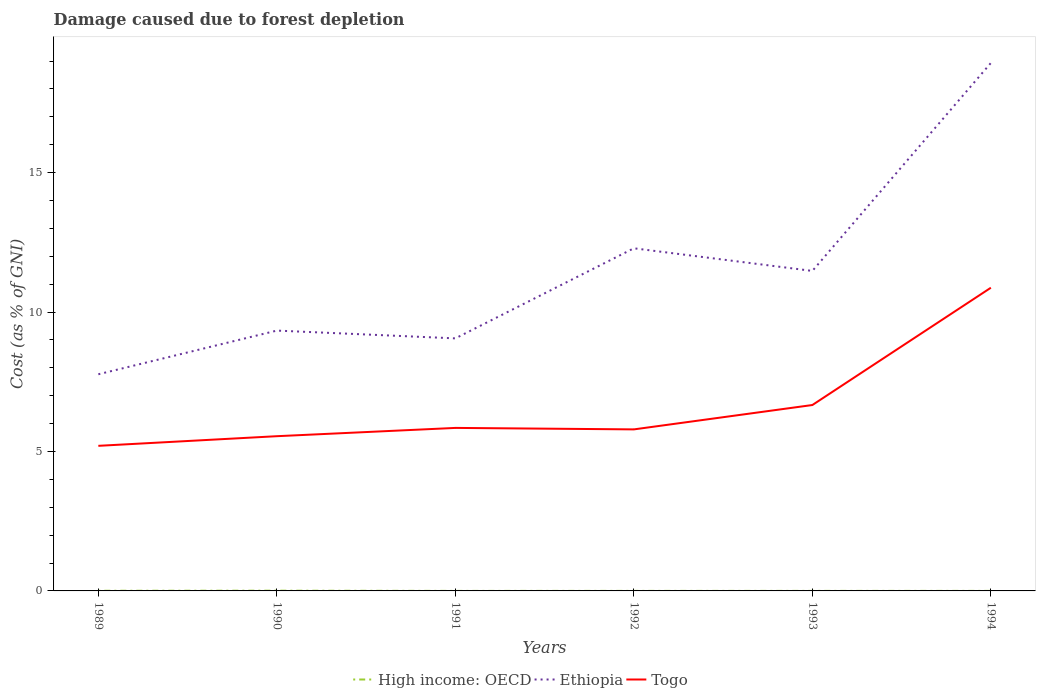Across all years, what is the maximum cost of damage caused due to forest depletion in High income: OECD?
Make the answer very short. 0. What is the total cost of damage caused due to forest depletion in High income: OECD in the graph?
Ensure brevity in your answer.  5.161181673698709e-7. What is the difference between the highest and the second highest cost of damage caused due to forest depletion in Ethiopia?
Your answer should be compact. 11.16. What is the difference between the highest and the lowest cost of damage caused due to forest depletion in Ethiopia?
Give a very brief answer. 2. What is the difference between two consecutive major ticks on the Y-axis?
Ensure brevity in your answer.  5. Are the values on the major ticks of Y-axis written in scientific E-notation?
Your response must be concise. No. Does the graph contain grids?
Provide a succinct answer. No. Where does the legend appear in the graph?
Offer a very short reply. Bottom center. What is the title of the graph?
Keep it short and to the point. Damage caused due to forest depletion. What is the label or title of the Y-axis?
Keep it short and to the point. Cost (as % of GNI). What is the Cost (as % of GNI) of High income: OECD in 1989?
Give a very brief answer. 0.01. What is the Cost (as % of GNI) of Ethiopia in 1989?
Give a very brief answer. 7.77. What is the Cost (as % of GNI) in Togo in 1989?
Your answer should be compact. 5.2. What is the Cost (as % of GNI) of High income: OECD in 1990?
Provide a short and direct response. 0.01. What is the Cost (as % of GNI) in Ethiopia in 1990?
Ensure brevity in your answer.  9.33. What is the Cost (as % of GNI) of Togo in 1990?
Provide a short and direct response. 5.55. What is the Cost (as % of GNI) of High income: OECD in 1991?
Your answer should be compact. 0. What is the Cost (as % of GNI) in Ethiopia in 1991?
Your answer should be very brief. 9.06. What is the Cost (as % of GNI) in Togo in 1991?
Offer a terse response. 5.85. What is the Cost (as % of GNI) in High income: OECD in 1992?
Ensure brevity in your answer.  0. What is the Cost (as % of GNI) of Ethiopia in 1992?
Offer a very short reply. 12.29. What is the Cost (as % of GNI) in Togo in 1992?
Keep it short and to the point. 5.79. What is the Cost (as % of GNI) of High income: OECD in 1993?
Offer a very short reply. 0. What is the Cost (as % of GNI) in Ethiopia in 1993?
Provide a succinct answer. 11.47. What is the Cost (as % of GNI) in Togo in 1993?
Provide a succinct answer. 6.67. What is the Cost (as % of GNI) in High income: OECD in 1994?
Offer a terse response. 0. What is the Cost (as % of GNI) in Ethiopia in 1994?
Ensure brevity in your answer.  18.93. What is the Cost (as % of GNI) in Togo in 1994?
Ensure brevity in your answer.  10.87. Across all years, what is the maximum Cost (as % of GNI) of High income: OECD?
Provide a succinct answer. 0.01. Across all years, what is the maximum Cost (as % of GNI) in Ethiopia?
Your answer should be compact. 18.93. Across all years, what is the maximum Cost (as % of GNI) in Togo?
Provide a succinct answer. 10.87. Across all years, what is the minimum Cost (as % of GNI) in High income: OECD?
Your response must be concise. 0. Across all years, what is the minimum Cost (as % of GNI) in Ethiopia?
Keep it short and to the point. 7.77. Across all years, what is the minimum Cost (as % of GNI) of Togo?
Make the answer very short. 5.2. What is the total Cost (as % of GNI) in High income: OECD in the graph?
Your response must be concise. 0.02. What is the total Cost (as % of GNI) of Ethiopia in the graph?
Your answer should be compact. 68.85. What is the total Cost (as % of GNI) in Togo in the graph?
Provide a succinct answer. 39.93. What is the difference between the Cost (as % of GNI) of High income: OECD in 1989 and that in 1990?
Offer a terse response. -0. What is the difference between the Cost (as % of GNI) of Ethiopia in 1989 and that in 1990?
Your response must be concise. -1.57. What is the difference between the Cost (as % of GNI) in Togo in 1989 and that in 1990?
Your response must be concise. -0.35. What is the difference between the Cost (as % of GNI) in High income: OECD in 1989 and that in 1991?
Your answer should be very brief. 0. What is the difference between the Cost (as % of GNI) of Ethiopia in 1989 and that in 1991?
Make the answer very short. -1.29. What is the difference between the Cost (as % of GNI) of Togo in 1989 and that in 1991?
Provide a succinct answer. -0.64. What is the difference between the Cost (as % of GNI) of High income: OECD in 1989 and that in 1992?
Your response must be concise. 0. What is the difference between the Cost (as % of GNI) of Ethiopia in 1989 and that in 1992?
Make the answer very short. -4.52. What is the difference between the Cost (as % of GNI) in Togo in 1989 and that in 1992?
Your response must be concise. -0.59. What is the difference between the Cost (as % of GNI) of High income: OECD in 1989 and that in 1993?
Provide a short and direct response. 0. What is the difference between the Cost (as % of GNI) in Ethiopia in 1989 and that in 1993?
Provide a short and direct response. -3.71. What is the difference between the Cost (as % of GNI) in Togo in 1989 and that in 1993?
Provide a succinct answer. -1.46. What is the difference between the Cost (as % of GNI) in High income: OECD in 1989 and that in 1994?
Your response must be concise. 0. What is the difference between the Cost (as % of GNI) of Ethiopia in 1989 and that in 1994?
Your answer should be compact. -11.16. What is the difference between the Cost (as % of GNI) of Togo in 1989 and that in 1994?
Your answer should be compact. -5.67. What is the difference between the Cost (as % of GNI) of High income: OECD in 1990 and that in 1991?
Make the answer very short. 0.01. What is the difference between the Cost (as % of GNI) in Ethiopia in 1990 and that in 1991?
Give a very brief answer. 0.28. What is the difference between the Cost (as % of GNI) in Togo in 1990 and that in 1991?
Provide a short and direct response. -0.3. What is the difference between the Cost (as % of GNI) of High income: OECD in 1990 and that in 1992?
Keep it short and to the point. 0.01. What is the difference between the Cost (as % of GNI) of Ethiopia in 1990 and that in 1992?
Your response must be concise. -2.95. What is the difference between the Cost (as % of GNI) in Togo in 1990 and that in 1992?
Make the answer very short. -0.24. What is the difference between the Cost (as % of GNI) in High income: OECD in 1990 and that in 1993?
Your answer should be very brief. 0.01. What is the difference between the Cost (as % of GNI) in Ethiopia in 1990 and that in 1993?
Your answer should be compact. -2.14. What is the difference between the Cost (as % of GNI) of Togo in 1990 and that in 1993?
Offer a very short reply. -1.12. What is the difference between the Cost (as % of GNI) of High income: OECD in 1990 and that in 1994?
Ensure brevity in your answer.  0.01. What is the difference between the Cost (as % of GNI) of Ethiopia in 1990 and that in 1994?
Make the answer very short. -9.6. What is the difference between the Cost (as % of GNI) of Togo in 1990 and that in 1994?
Offer a terse response. -5.32. What is the difference between the Cost (as % of GNI) of High income: OECD in 1991 and that in 1992?
Provide a short and direct response. -0. What is the difference between the Cost (as % of GNI) in Ethiopia in 1991 and that in 1992?
Your response must be concise. -3.23. What is the difference between the Cost (as % of GNI) in Togo in 1991 and that in 1992?
Your response must be concise. 0.05. What is the difference between the Cost (as % of GNI) of High income: OECD in 1991 and that in 1993?
Your response must be concise. -0. What is the difference between the Cost (as % of GNI) in Ethiopia in 1991 and that in 1993?
Provide a succinct answer. -2.42. What is the difference between the Cost (as % of GNI) of Togo in 1991 and that in 1993?
Keep it short and to the point. -0.82. What is the difference between the Cost (as % of GNI) of High income: OECD in 1991 and that in 1994?
Offer a terse response. -0. What is the difference between the Cost (as % of GNI) in Ethiopia in 1991 and that in 1994?
Provide a succinct answer. -9.88. What is the difference between the Cost (as % of GNI) in Togo in 1991 and that in 1994?
Offer a very short reply. -5.03. What is the difference between the Cost (as % of GNI) in High income: OECD in 1992 and that in 1993?
Offer a terse response. -0. What is the difference between the Cost (as % of GNI) in Ethiopia in 1992 and that in 1993?
Ensure brevity in your answer.  0.81. What is the difference between the Cost (as % of GNI) of Togo in 1992 and that in 1993?
Your response must be concise. -0.87. What is the difference between the Cost (as % of GNI) in High income: OECD in 1992 and that in 1994?
Give a very brief answer. -0. What is the difference between the Cost (as % of GNI) of Ethiopia in 1992 and that in 1994?
Your response must be concise. -6.65. What is the difference between the Cost (as % of GNI) of Togo in 1992 and that in 1994?
Offer a very short reply. -5.08. What is the difference between the Cost (as % of GNI) of High income: OECD in 1993 and that in 1994?
Your answer should be compact. 0. What is the difference between the Cost (as % of GNI) in Ethiopia in 1993 and that in 1994?
Keep it short and to the point. -7.46. What is the difference between the Cost (as % of GNI) of Togo in 1993 and that in 1994?
Ensure brevity in your answer.  -4.21. What is the difference between the Cost (as % of GNI) of High income: OECD in 1989 and the Cost (as % of GNI) of Ethiopia in 1990?
Provide a succinct answer. -9.33. What is the difference between the Cost (as % of GNI) of High income: OECD in 1989 and the Cost (as % of GNI) of Togo in 1990?
Provide a succinct answer. -5.54. What is the difference between the Cost (as % of GNI) of Ethiopia in 1989 and the Cost (as % of GNI) of Togo in 1990?
Ensure brevity in your answer.  2.22. What is the difference between the Cost (as % of GNI) in High income: OECD in 1989 and the Cost (as % of GNI) in Ethiopia in 1991?
Your answer should be very brief. -9.05. What is the difference between the Cost (as % of GNI) of High income: OECD in 1989 and the Cost (as % of GNI) of Togo in 1991?
Make the answer very short. -5.84. What is the difference between the Cost (as % of GNI) of Ethiopia in 1989 and the Cost (as % of GNI) of Togo in 1991?
Your response must be concise. 1.92. What is the difference between the Cost (as % of GNI) of High income: OECD in 1989 and the Cost (as % of GNI) of Ethiopia in 1992?
Make the answer very short. -12.28. What is the difference between the Cost (as % of GNI) in High income: OECD in 1989 and the Cost (as % of GNI) in Togo in 1992?
Provide a short and direct response. -5.79. What is the difference between the Cost (as % of GNI) of Ethiopia in 1989 and the Cost (as % of GNI) of Togo in 1992?
Offer a very short reply. 1.98. What is the difference between the Cost (as % of GNI) in High income: OECD in 1989 and the Cost (as % of GNI) in Ethiopia in 1993?
Provide a short and direct response. -11.47. What is the difference between the Cost (as % of GNI) of High income: OECD in 1989 and the Cost (as % of GNI) of Togo in 1993?
Ensure brevity in your answer.  -6.66. What is the difference between the Cost (as % of GNI) in Ethiopia in 1989 and the Cost (as % of GNI) in Togo in 1993?
Offer a very short reply. 1.1. What is the difference between the Cost (as % of GNI) in High income: OECD in 1989 and the Cost (as % of GNI) in Ethiopia in 1994?
Provide a short and direct response. -18.93. What is the difference between the Cost (as % of GNI) in High income: OECD in 1989 and the Cost (as % of GNI) in Togo in 1994?
Provide a succinct answer. -10.87. What is the difference between the Cost (as % of GNI) in Ethiopia in 1989 and the Cost (as % of GNI) in Togo in 1994?
Your response must be concise. -3.1. What is the difference between the Cost (as % of GNI) in High income: OECD in 1990 and the Cost (as % of GNI) in Ethiopia in 1991?
Your answer should be very brief. -9.05. What is the difference between the Cost (as % of GNI) of High income: OECD in 1990 and the Cost (as % of GNI) of Togo in 1991?
Keep it short and to the point. -5.84. What is the difference between the Cost (as % of GNI) of Ethiopia in 1990 and the Cost (as % of GNI) of Togo in 1991?
Your answer should be compact. 3.49. What is the difference between the Cost (as % of GNI) in High income: OECD in 1990 and the Cost (as % of GNI) in Ethiopia in 1992?
Your response must be concise. -12.28. What is the difference between the Cost (as % of GNI) of High income: OECD in 1990 and the Cost (as % of GNI) of Togo in 1992?
Give a very brief answer. -5.78. What is the difference between the Cost (as % of GNI) of Ethiopia in 1990 and the Cost (as % of GNI) of Togo in 1992?
Ensure brevity in your answer.  3.54. What is the difference between the Cost (as % of GNI) in High income: OECD in 1990 and the Cost (as % of GNI) in Ethiopia in 1993?
Provide a short and direct response. -11.47. What is the difference between the Cost (as % of GNI) of High income: OECD in 1990 and the Cost (as % of GNI) of Togo in 1993?
Keep it short and to the point. -6.66. What is the difference between the Cost (as % of GNI) in Ethiopia in 1990 and the Cost (as % of GNI) in Togo in 1993?
Offer a very short reply. 2.67. What is the difference between the Cost (as % of GNI) of High income: OECD in 1990 and the Cost (as % of GNI) of Ethiopia in 1994?
Provide a succinct answer. -18.92. What is the difference between the Cost (as % of GNI) of High income: OECD in 1990 and the Cost (as % of GNI) of Togo in 1994?
Offer a terse response. -10.86. What is the difference between the Cost (as % of GNI) in Ethiopia in 1990 and the Cost (as % of GNI) in Togo in 1994?
Provide a short and direct response. -1.54. What is the difference between the Cost (as % of GNI) of High income: OECD in 1991 and the Cost (as % of GNI) of Ethiopia in 1992?
Offer a very short reply. -12.29. What is the difference between the Cost (as % of GNI) of High income: OECD in 1991 and the Cost (as % of GNI) of Togo in 1992?
Ensure brevity in your answer.  -5.79. What is the difference between the Cost (as % of GNI) in Ethiopia in 1991 and the Cost (as % of GNI) in Togo in 1992?
Provide a short and direct response. 3.26. What is the difference between the Cost (as % of GNI) in High income: OECD in 1991 and the Cost (as % of GNI) in Ethiopia in 1993?
Your response must be concise. -11.47. What is the difference between the Cost (as % of GNI) in High income: OECD in 1991 and the Cost (as % of GNI) in Togo in 1993?
Offer a very short reply. -6.67. What is the difference between the Cost (as % of GNI) of Ethiopia in 1991 and the Cost (as % of GNI) of Togo in 1993?
Keep it short and to the point. 2.39. What is the difference between the Cost (as % of GNI) of High income: OECD in 1991 and the Cost (as % of GNI) of Ethiopia in 1994?
Your response must be concise. -18.93. What is the difference between the Cost (as % of GNI) in High income: OECD in 1991 and the Cost (as % of GNI) in Togo in 1994?
Your answer should be compact. -10.87. What is the difference between the Cost (as % of GNI) in Ethiopia in 1991 and the Cost (as % of GNI) in Togo in 1994?
Give a very brief answer. -1.82. What is the difference between the Cost (as % of GNI) of High income: OECD in 1992 and the Cost (as % of GNI) of Ethiopia in 1993?
Keep it short and to the point. -11.47. What is the difference between the Cost (as % of GNI) in High income: OECD in 1992 and the Cost (as % of GNI) in Togo in 1993?
Offer a terse response. -6.66. What is the difference between the Cost (as % of GNI) of Ethiopia in 1992 and the Cost (as % of GNI) of Togo in 1993?
Your answer should be compact. 5.62. What is the difference between the Cost (as % of GNI) in High income: OECD in 1992 and the Cost (as % of GNI) in Ethiopia in 1994?
Your answer should be compact. -18.93. What is the difference between the Cost (as % of GNI) in High income: OECD in 1992 and the Cost (as % of GNI) in Togo in 1994?
Your answer should be compact. -10.87. What is the difference between the Cost (as % of GNI) in Ethiopia in 1992 and the Cost (as % of GNI) in Togo in 1994?
Your response must be concise. 1.41. What is the difference between the Cost (as % of GNI) of High income: OECD in 1993 and the Cost (as % of GNI) of Ethiopia in 1994?
Provide a short and direct response. -18.93. What is the difference between the Cost (as % of GNI) of High income: OECD in 1993 and the Cost (as % of GNI) of Togo in 1994?
Offer a terse response. -10.87. What is the difference between the Cost (as % of GNI) in Ethiopia in 1993 and the Cost (as % of GNI) in Togo in 1994?
Make the answer very short. 0.6. What is the average Cost (as % of GNI) of High income: OECD per year?
Provide a short and direct response. 0. What is the average Cost (as % of GNI) in Ethiopia per year?
Offer a very short reply. 11.48. What is the average Cost (as % of GNI) in Togo per year?
Provide a succinct answer. 6.65. In the year 1989, what is the difference between the Cost (as % of GNI) in High income: OECD and Cost (as % of GNI) in Ethiopia?
Ensure brevity in your answer.  -7.76. In the year 1989, what is the difference between the Cost (as % of GNI) of High income: OECD and Cost (as % of GNI) of Togo?
Your response must be concise. -5.2. In the year 1989, what is the difference between the Cost (as % of GNI) of Ethiopia and Cost (as % of GNI) of Togo?
Keep it short and to the point. 2.57. In the year 1990, what is the difference between the Cost (as % of GNI) in High income: OECD and Cost (as % of GNI) in Ethiopia?
Offer a very short reply. -9.33. In the year 1990, what is the difference between the Cost (as % of GNI) in High income: OECD and Cost (as % of GNI) in Togo?
Give a very brief answer. -5.54. In the year 1990, what is the difference between the Cost (as % of GNI) of Ethiopia and Cost (as % of GNI) of Togo?
Provide a short and direct response. 3.79. In the year 1991, what is the difference between the Cost (as % of GNI) in High income: OECD and Cost (as % of GNI) in Ethiopia?
Offer a terse response. -9.05. In the year 1991, what is the difference between the Cost (as % of GNI) of High income: OECD and Cost (as % of GNI) of Togo?
Offer a very short reply. -5.84. In the year 1991, what is the difference between the Cost (as % of GNI) in Ethiopia and Cost (as % of GNI) in Togo?
Your response must be concise. 3.21. In the year 1992, what is the difference between the Cost (as % of GNI) of High income: OECD and Cost (as % of GNI) of Ethiopia?
Keep it short and to the point. -12.29. In the year 1992, what is the difference between the Cost (as % of GNI) in High income: OECD and Cost (as % of GNI) in Togo?
Ensure brevity in your answer.  -5.79. In the year 1992, what is the difference between the Cost (as % of GNI) in Ethiopia and Cost (as % of GNI) in Togo?
Offer a very short reply. 6.49. In the year 1993, what is the difference between the Cost (as % of GNI) in High income: OECD and Cost (as % of GNI) in Ethiopia?
Offer a very short reply. -11.47. In the year 1993, what is the difference between the Cost (as % of GNI) in High income: OECD and Cost (as % of GNI) in Togo?
Your response must be concise. -6.66. In the year 1993, what is the difference between the Cost (as % of GNI) in Ethiopia and Cost (as % of GNI) in Togo?
Give a very brief answer. 4.81. In the year 1994, what is the difference between the Cost (as % of GNI) of High income: OECD and Cost (as % of GNI) of Ethiopia?
Your answer should be very brief. -18.93. In the year 1994, what is the difference between the Cost (as % of GNI) in High income: OECD and Cost (as % of GNI) in Togo?
Your answer should be compact. -10.87. In the year 1994, what is the difference between the Cost (as % of GNI) of Ethiopia and Cost (as % of GNI) of Togo?
Your response must be concise. 8.06. What is the ratio of the Cost (as % of GNI) of High income: OECD in 1989 to that in 1990?
Your answer should be compact. 0.65. What is the ratio of the Cost (as % of GNI) of Ethiopia in 1989 to that in 1990?
Your answer should be very brief. 0.83. What is the ratio of the Cost (as % of GNI) in Togo in 1989 to that in 1990?
Give a very brief answer. 0.94. What is the ratio of the Cost (as % of GNI) of High income: OECD in 1989 to that in 1991?
Your answer should be compact. 7.32. What is the ratio of the Cost (as % of GNI) in Ethiopia in 1989 to that in 1991?
Give a very brief answer. 0.86. What is the ratio of the Cost (as % of GNI) in Togo in 1989 to that in 1991?
Your answer should be compact. 0.89. What is the ratio of the Cost (as % of GNI) of High income: OECD in 1989 to that in 1992?
Provide a succinct answer. 5.61. What is the ratio of the Cost (as % of GNI) in Ethiopia in 1989 to that in 1992?
Give a very brief answer. 0.63. What is the ratio of the Cost (as % of GNI) in Togo in 1989 to that in 1992?
Make the answer very short. 0.9. What is the ratio of the Cost (as % of GNI) in High income: OECD in 1989 to that in 1993?
Your response must be concise. 5.16. What is the ratio of the Cost (as % of GNI) of Ethiopia in 1989 to that in 1993?
Make the answer very short. 0.68. What is the ratio of the Cost (as % of GNI) of Togo in 1989 to that in 1993?
Ensure brevity in your answer.  0.78. What is the ratio of the Cost (as % of GNI) in High income: OECD in 1989 to that in 1994?
Give a very brief answer. 5.16. What is the ratio of the Cost (as % of GNI) of Ethiopia in 1989 to that in 1994?
Keep it short and to the point. 0.41. What is the ratio of the Cost (as % of GNI) in Togo in 1989 to that in 1994?
Keep it short and to the point. 0.48. What is the ratio of the Cost (as % of GNI) of High income: OECD in 1990 to that in 1991?
Keep it short and to the point. 11.27. What is the ratio of the Cost (as % of GNI) in Ethiopia in 1990 to that in 1991?
Give a very brief answer. 1.03. What is the ratio of the Cost (as % of GNI) of Togo in 1990 to that in 1991?
Keep it short and to the point. 0.95. What is the ratio of the Cost (as % of GNI) of High income: OECD in 1990 to that in 1992?
Offer a very short reply. 8.63. What is the ratio of the Cost (as % of GNI) in Ethiopia in 1990 to that in 1992?
Provide a short and direct response. 0.76. What is the ratio of the Cost (as % of GNI) in Togo in 1990 to that in 1992?
Give a very brief answer. 0.96. What is the ratio of the Cost (as % of GNI) in High income: OECD in 1990 to that in 1993?
Make the answer very short. 7.94. What is the ratio of the Cost (as % of GNI) of Ethiopia in 1990 to that in 1993?
Offer a very short reply. 0.81. What is the ratio of the Cost (as % of GNI) in Togo in 1990 to that in 1993?
Provide a succinct answer. 0.83. What is the ratio of the Cost (as % of GNI) of High income: OECD in 1990 to that in 1994?
Your response must be concise. 7.94. What is the ratio of the Cost (as % of GNI) of Ethiopia in 1990 to that in 1994?
Make the answer very short. 0.49. What is the ratio of the Cost (as % of GNI) in Togo in 1990 to that in 1994?
Ensure brevity in your answer.  0.51. What is the ratio of the Cost (as % of GNI) of High income: OECD in 1991 to that in 1992?
Your response must be concise. 0.77. What is the ratio of the Cost (as % of GNI) of Ethiopia in 1991 to that in 1992?
Offer a very short reply. 0.74. What is the ratio of the Cost (as % of GNI) of Togo in 1991 to that in 1992?
Ensure brevity in your answer.  1.01. What is the ratio of the Cost (as % of GNI) of High income: OECD in 1991 to that in 1993?
Your answer should be very brief. 0.7. What is the ratio of the Cost (as % of GNI) in Ethiopia in 1991 to that in 1993?
Offer a very short reply. 0.79. What is the ratio of the Cost (as % of GNI) of Togo in 1991 to that in 1993?
Your answer should be compact. 0.88. What is the ratio of the Cost (as % of GNI) of High income: OECD in 1991 to that in 1994?
Give a very brief answer. 0.7. What is the ratio of the Cost (as % of GNI) of Ethiopia in 1991 to that in 1994?
Offer a terse response. 0.48. What is the ratio of the Cost (as % of GNI) in Togo in 1991 to that in 1994?
Your response must be concise. 0.54. What is the ratio of the Cost (as % of GNI) in High income: OECD in 1992 to that in 1993?
Your response must be concise. 0.92. What is the ratio of the Cost (as % of GNI) in Ethiopia in 1992 to that in 1993?
Provide a short and direct response. 1.07. What is the ratio of the Cost (as % of GNI) in Togo in 1992 to that in 1993?
Your answer should be compact. 0.87. What is the ratio of the Cost (as % of GNI) in High income: OECD in 1992 to that in 1994?
Make the answer very short. 0.92. What is the ratio of the Cost (as % of GNI) of Ethiopia in 1992 to that in 1994?
Your answer should be very brief. 0.65. What is the ratio of the Cost (as % of GNI) in Togo in 1992 to that in 1994?
Make the answer very short. 0.53. What is the ratio of the Cost (as % of GNI) of High income: OECD in 1993 to that in 1994?
Give a very brief answer. 1. What is the ratio of the Cost (as % of GNI) of Ethiopia in 1993 to that in 1994?
Give a very brief answer. 0.61. What is the ratio of the Cost (as % of GNI) of Togo in 1993 to that in 1994?
Provide a succinct answer. 0.61. What is the difference between the highest and the second highest Cost (as % of GNI) in High income: OECD?
Give a very brief answer. 0. What is the difference between the highest and the second highest Cost (as % of GNI) in Ethiopia?
Offer a terse response. 6.65. What is the difference between the highest and the second highest Cost (as % of GNI) in Togo?
Give a very brief answer. 4.21. What is the difference between the highest and the lowest Cost (as % of GNI) of High income: OECD?
Make the answer very short. 0.01. What is the difference between the highest and the lowest Cost (as % of GNI) of Ethiopia?
Give a very brief answer. 11.16. What is the difference between the highest and the lowest Cost (as % of GNI) in Togo?
Your response must be concise. 5.67. 